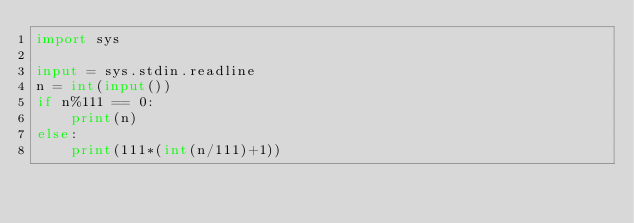Convert code to text. <code><loc_0><loc_0><loc_500><loc_500><_Python_>import sys

input = sys.stdin.readline
n = int(input())
if n%111 == 0:
    print(n)
else:
    print(111*(int(n/111)+1))
</code> 